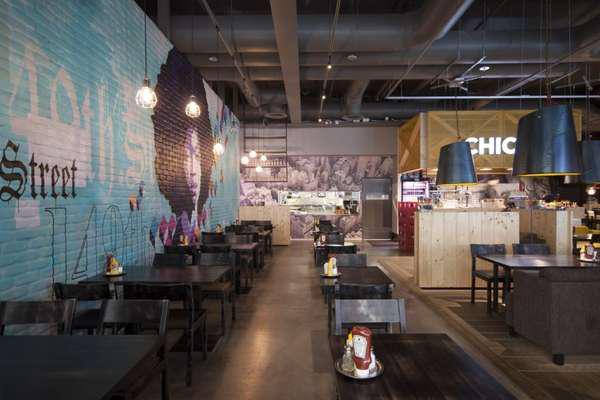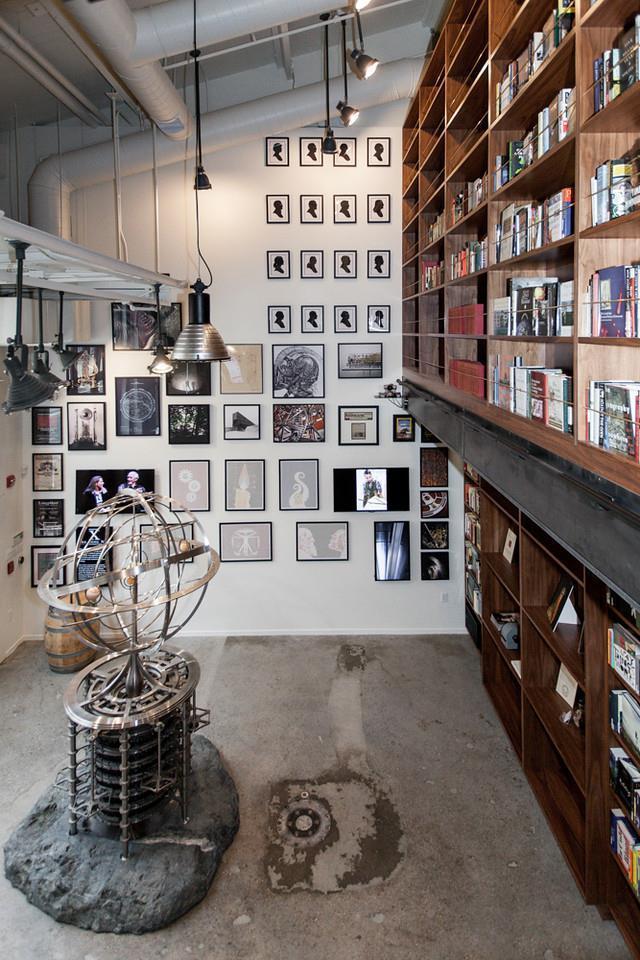The first image is the image on the left, the second image is the image on the right. For the images displayed, is the sentence "An image shows the front of an eatery inside a bigger building, with signage that includes bright green color and a red fruit." factually correct? Answer yes or no. No. 